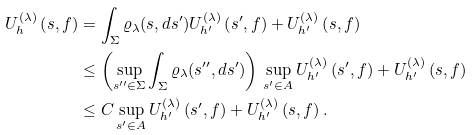<formula> <loc_0><loc_0><loc_500><loc_500>U ^ { ( \lambda ) } _ { h } \left ( s , f \right ) & = \int _ { \Sigma } \varrho _ { \lambda } ( s , d s ^ { \prime } ) U ^ { ( \lambda ) } _ { h ^ { \prime } } \left ( s ^ { \prime } , f \right ) + U ^ { ( \lambda ) } _ { h ^ { \prime } } \left ( s , f \right ) \\ & \leq \left ( \sup _ { s ^ { \prime \prime } \in \Sigma } \int _ { \Sigma } \varrho _ { \lambda } ( s ^ { \prime \prime } , d s ^ { \prime } ) \right ) \, \sup _ { s ^ { \prime } \in A } U ^ { ( \lambda ) } _ { h ^ { \prime } } \left ( s ^ { \prime } , f \right ) + U ^ { ( \lambda ) } _ { h ^ { \prime } } \left ( s , f \right ) \\ & \leq C \sup _ { s ^ { \prime } \in A } U ^ { ( \lambda ) } _ { h ^ { \prime } } \left ( s ^ { \prime } , f \right ) + U ^ { ( \lambda ) } _ { h ^ { \prime } } \left ( s , f \right ) .</formula> 